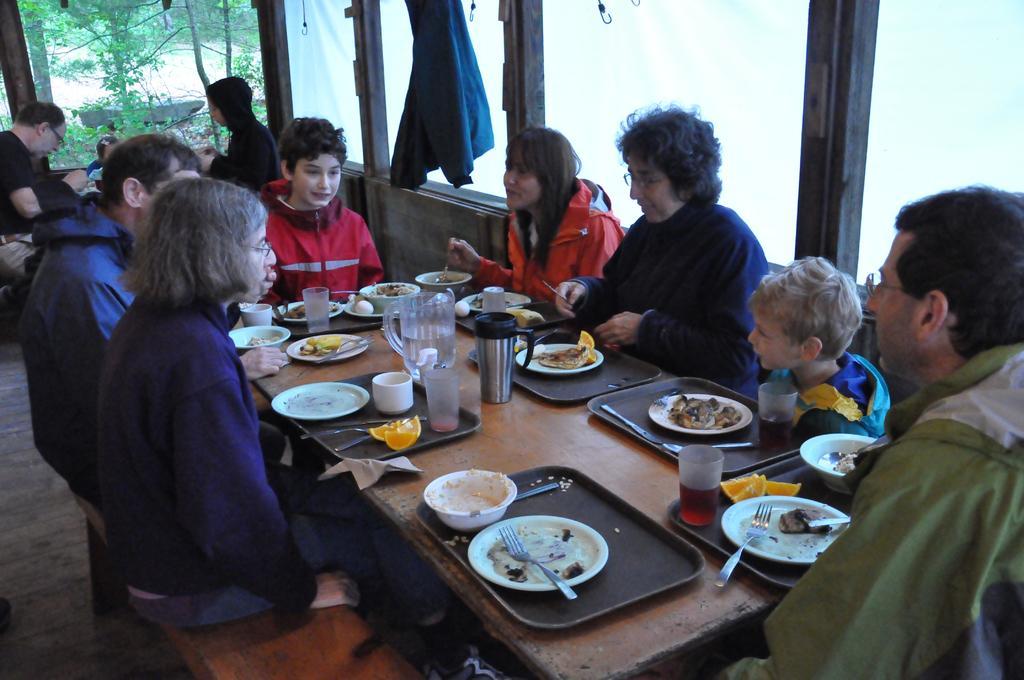Can you describe this image briefly? There are group of persons sitting on the table having their food and there is a jug of water on the table and glasses which contains different soft drinks and water ,left side of the image there are three persons sitting over there having their food at the left there are trees which we can see through window and at the middle of the image there is a jacket which is hanged to the window 